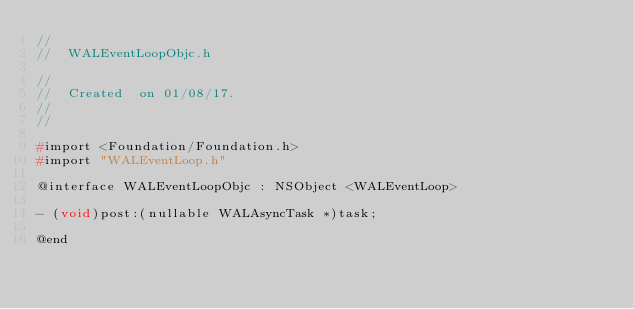Convert code to text. <code><loc_0><loc_0><loc_500><loc_500><_C_>//
//  WALEventLoopObjc.h

//
//  Created  on 01/08/17.
//  
//

#import <Foundation/Foundation.h>
#import "WALEventLoop.h"

@interface WALEventLoopObjc : NSObject <WALEventLoop>

- (void)post:(nullable WALAsyncTask *)task;

@end
</code> 